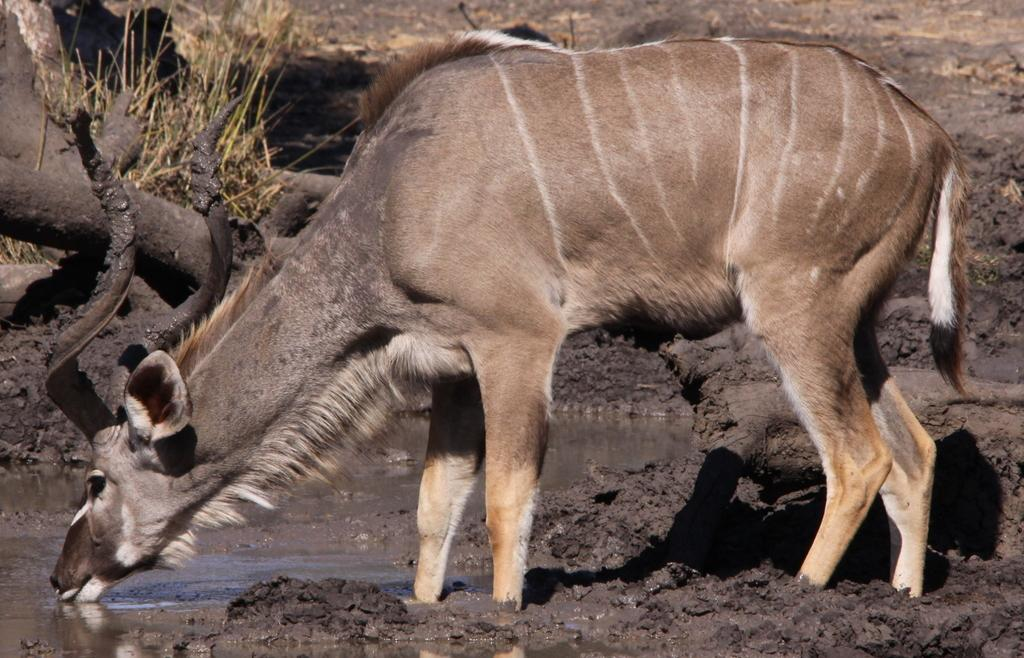What animal is in the middle of the image? There is a KUDU in the middle of the image. What is present at the bottom of the image? There is water at the bottom of the image. Where can some grass be found in the image? There is some grass at the top left corner of the image. What type of record can be seen playing in the image? There is no record player or record visible in the image. 